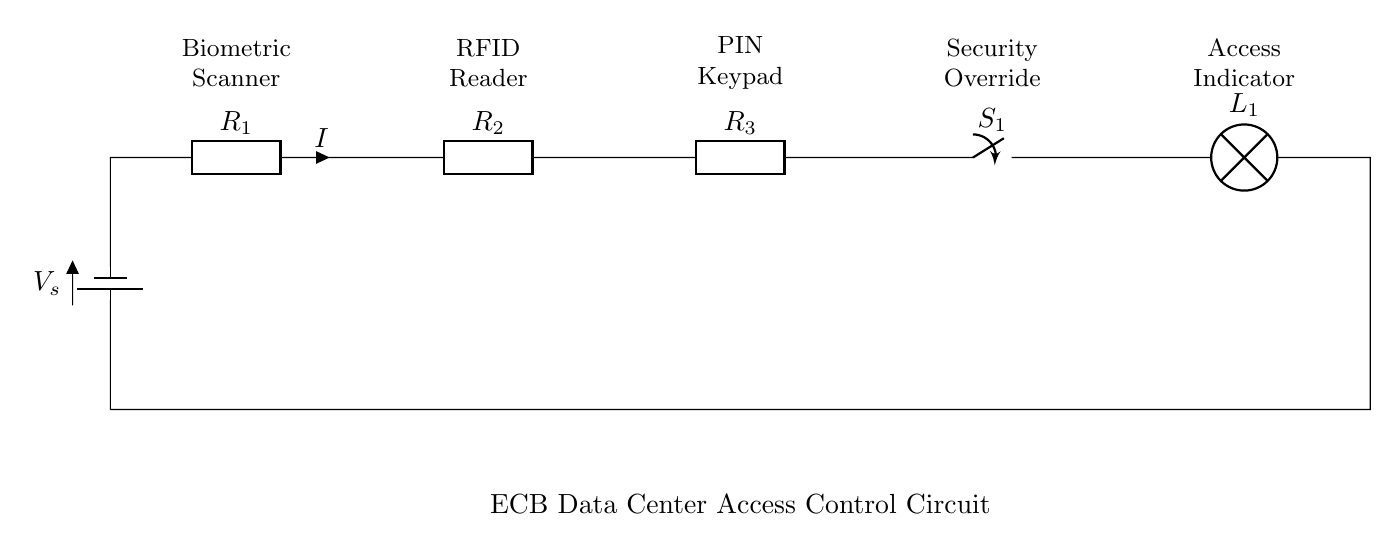What is the voltage source symbol in the circuit? The voltage source symbol is represented at the left side of the circuit, labeled as V_s.
Answer: V_s What components are in series in the circuit? The components in series are R_1, R_2, R_3, the switch S_1, and the lamp L_1, all connected in a single path.
Answer: R_1, R_2, R_3, S_1, L_1 How many resistors are present in the circuit? The circuit contains three resistors labeled R_1, R_2, and R_3, which are all arranged in series.
Answer: Three What is the function of the switch in this circuit? The switch S_1 controls the flow of current in the circuit, allowing or interrupting the operation of the access control system.
Answer: Control current What happens to the current if the switch is open? If the switch S_1 is open, the circuit is incomplete, and no current will flow through the components, which means the entire system will be inactive.
Answer: No current flows If all components are functioning properly, what will illuminate when access is granted? When the access is granted and current flows through the circuit, the lamp L_1 will illuminate to indicate successful access.
Answer: Lamp L_1 